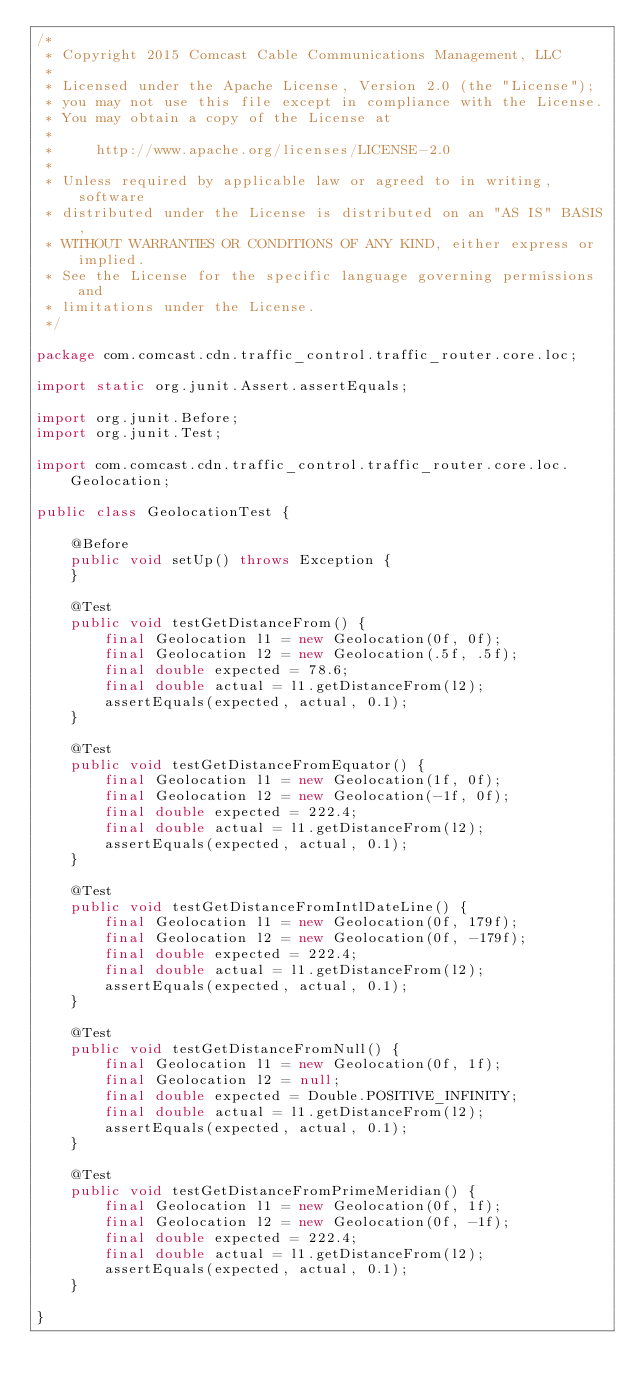Convert code to text. <code><loc_0><loc_0><loc_500><loc_500><_Java_>/*
 * Copyright 2015 Comcast Cable Communications Management, LLC
 *
 * Licensed under the Apache License, Version 2.0 (the "License");
 * you may not use this file except in compliance with the License.
 * You may obtain a copy of the License at
 *
 *     http://www.apache.org/licenses/LICENSE-2.0
 *
 * Unless required by applicable law or agreed to in writing, software
 * distributed under the License is distributed on an "AS IS" BASIS,
 * WITHOUT WARRANTIES OR CONDITIONS OF ANY KIND, either express or implied.
 * See the License for the specific language governing permissions and
 * limitations under the License.
 */

package com.comcast.cdn.traffic_control.traffic_router.core.loc;

import static org.junit.Assert.assertEquals;

import org.junit.Before;
import org.junit.Test;

import com.comcast.cdn.traffic_control.traffic_router.core.loc.Geolocation;

public class GeolocationTest {

    @Before
    public void setUp() throws Exception {
    }

    @Test
    public void testGetDistanceFrom() {
        final Geolocation l1 = new Geolocation(0f, 0f);
        final Geolocation l2 = new Geolocation(.5f, .5f);
        final double expected = 78.6;
        final double actual = l1.getDistanceFrom(l2);
        assertEquals(expected, actual, 0.1);
    }

    @Test
    public void testGetDistanceFromEquator() {
        final Geolocation l1 = new Geolocation(1f, 0f);
        final Geolocation l2 = new Geolocation(-1f, 0f);
        final double expected = 222.4;
        final double actual = l1.getDistanceFrom(l2);
        assertEquals(expected, actual, 0.1);
    }

    @Test
    public void testGetDistanceFromIntlDateLine() {
        final Geolocation l1 = new Geolocation(0f, 179f);
        final Geolocation l2 = new Geolocation(0f, -179f);
        final double expected = 222.4;
        final double actual = l1.getDistanceFrom(l2);
        assertEquals(expected, actual, 0.1);
    }

    @Test
    public void testGetDistanceFromNull() {
        final Geolocation l1 = new Geolocation(0f, 1f);
        final Geolocation l2 = null;
        final double expected = Double.POSITIVE_INFINITY;
        final double actual = l1.getDistanceFrom(l2);
        assertEquals(expected, actual, 0.1);
    }

    @Test
    public void testGetDistanceFromPrimeMeridian() {
        final Geolocation l1 = new Geolocation(0f, 1f);
        final Geolocation l2 = new Geolocation(0f, -1f);
        final double expected = 222.4;
        final double actual = l1.getDistanceFrom(l2);
        assertEquals(expected, actual, 0.1);
    }

}
</code> 